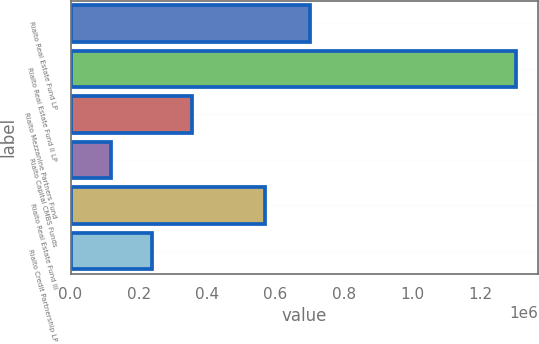<chart> <loc_0><loc_0><loc_500><loc_500><bar_chart><fcel>Rialto Real Estate Fund LP<fcel>Rialto Real Estate Fund II LP<fcel>Rialto Mezzanine Partners Fund<fcel>Rialto Capital CMBS Funds<fcel>Rialto Real Estate Fund III<fcel>Rialto Credit Partnership LP<nl><fcel>700006<fcel>1.305e+06<fcel>356339<fcel>119174<fcel>569482<fcel>237757<nl></chart> 